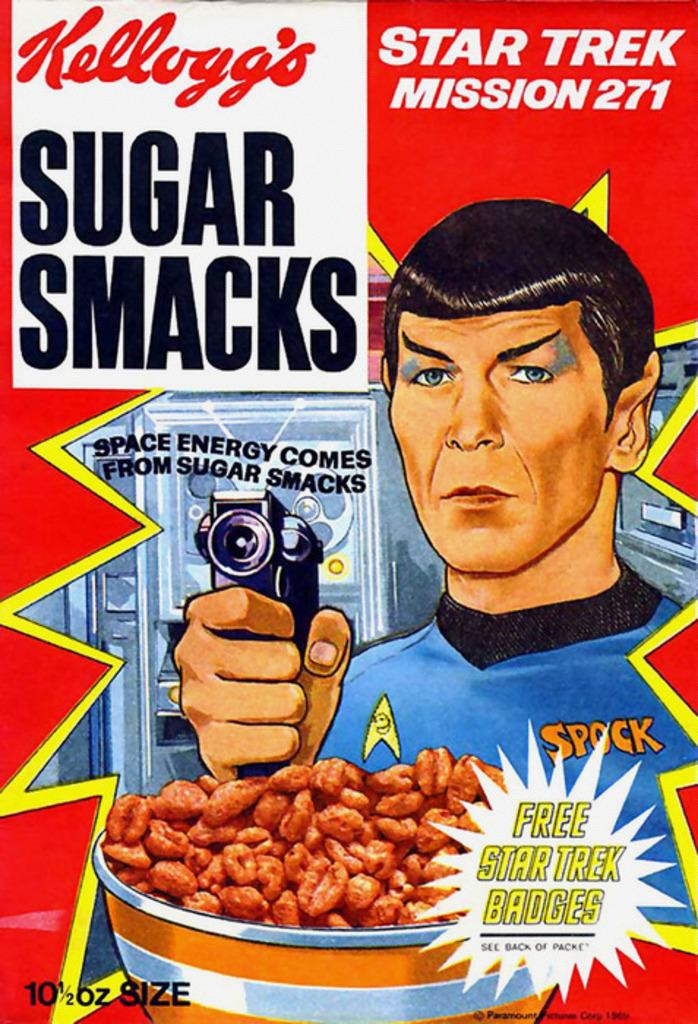What is present on the poster in the image? There is a poster in the image. What is the main subject of the poster? The poster features a person holding an object. Are there any other elements on the poster besides the person and the object? Yes, there are other things depicted on the poster. What type of milk is being poured by the monkey on the poster? There is no monkey present on the poster, and therefore no milk being poured. 